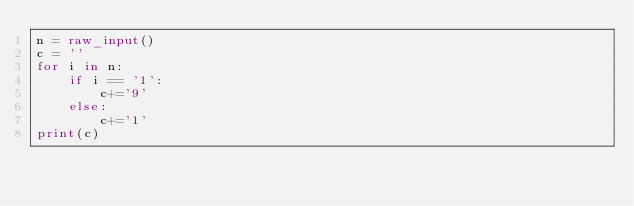Convert code to text. <code><loc_0><loc_0><loc_500><loc_500><_Python_>n = raw_input()
c = ''
for i in n:
    if i == '1':
        c+='9'
    else:
        c+='1'
print(c)</code> 